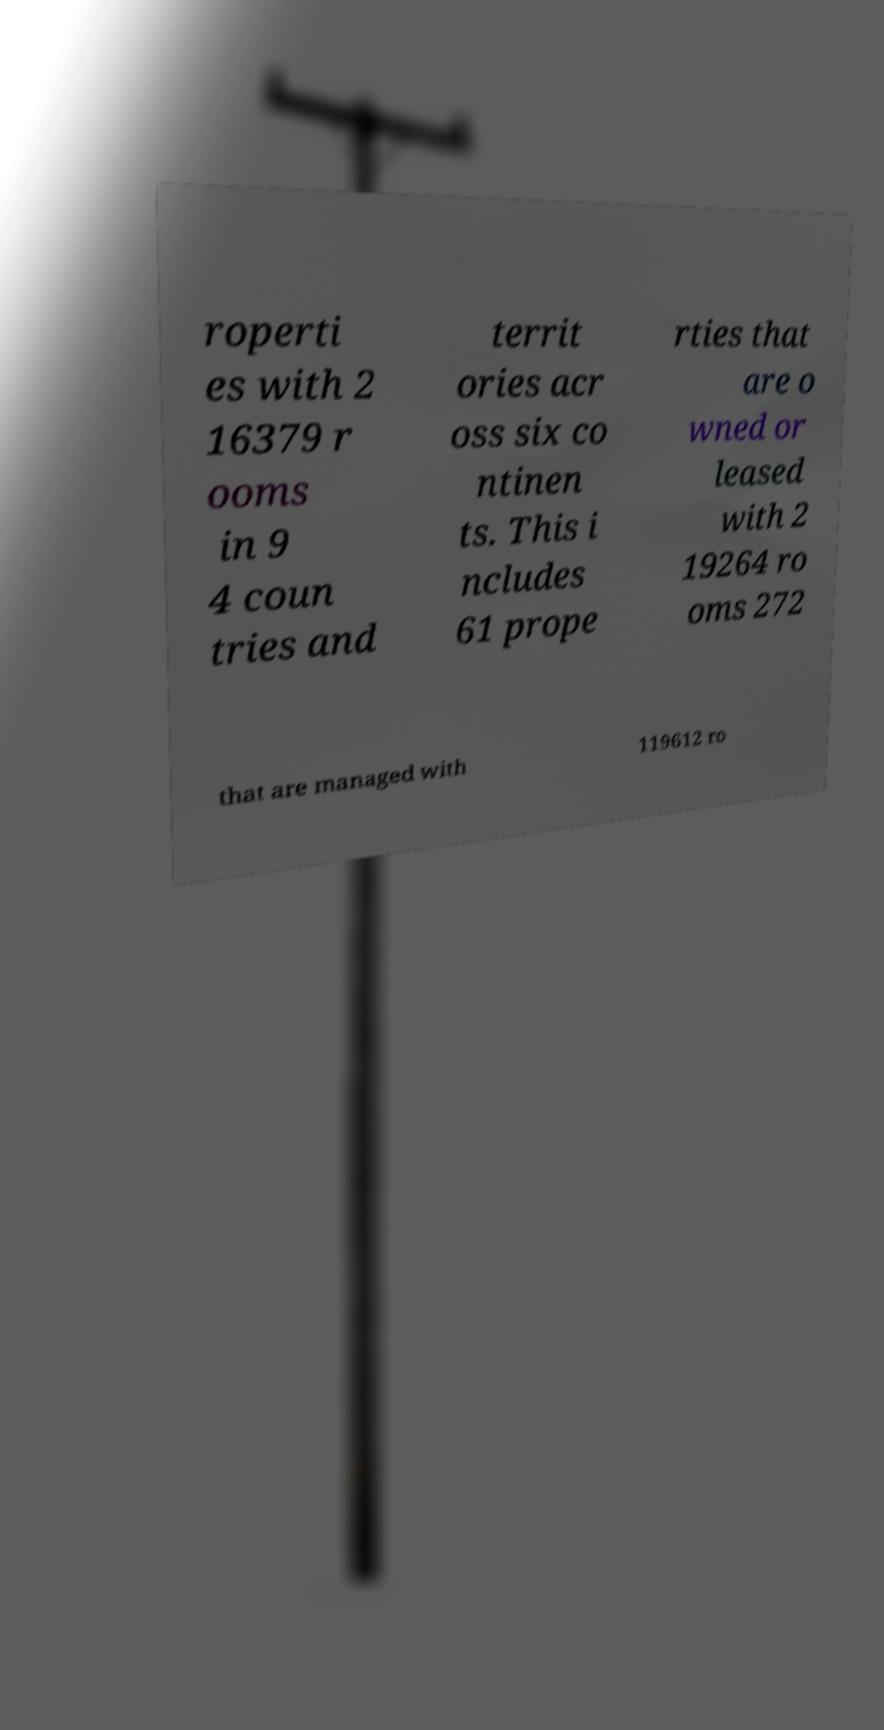Can you read and provide the text displayed in the image?This photo seems to have some interesting text. Can you extract and type it out for me? roperti es with 2 16379 r ooms in 9 4 coun tries and territ ories acr oss six co ntinen ts. This i ncludes 61 prope rties that are o wned or leased with 2 19264 ro oms 272 that are managed with 119612 ro 